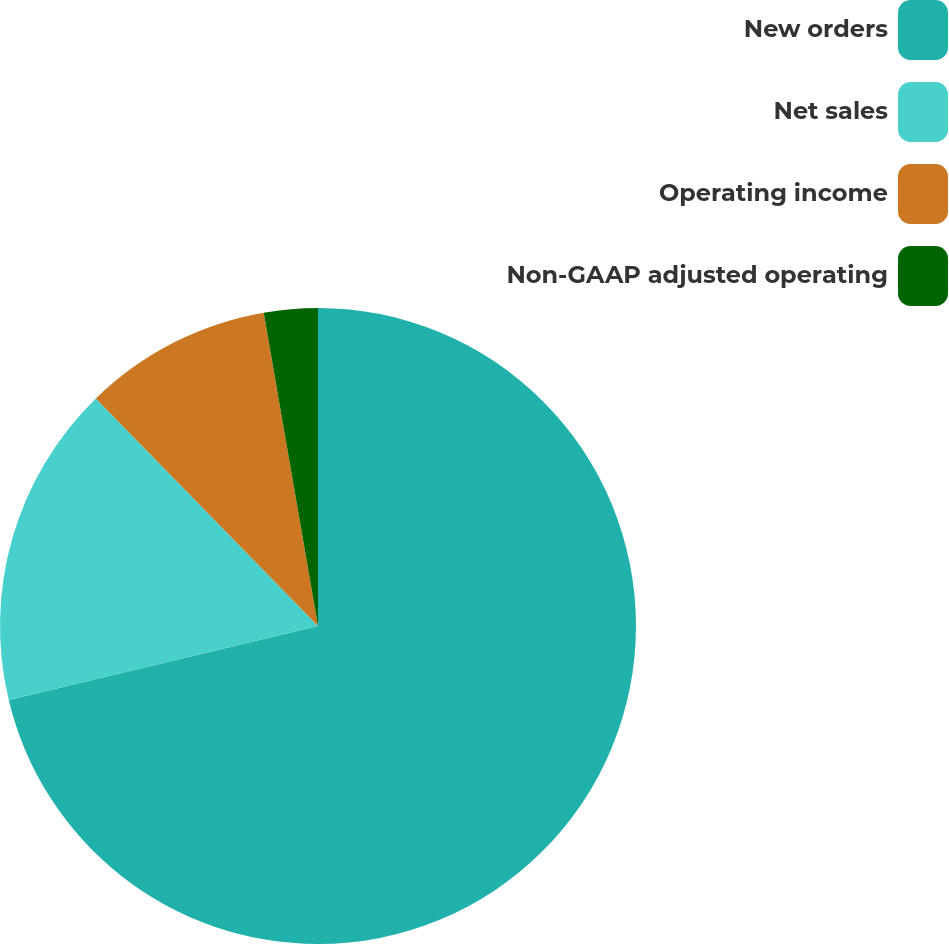Convert chart to OTSL. <chart><loc_0><loc_0><loc_500><loc_500><pie_chart><fcel>New orders<fcel>Net sales<fcel>Operating income<fcel>Non-GAAP adjusted operating<nl><fcel>71.26%<fcel>16.43%<fcel>9.58%<fcel>2.73%<nl></chart> 